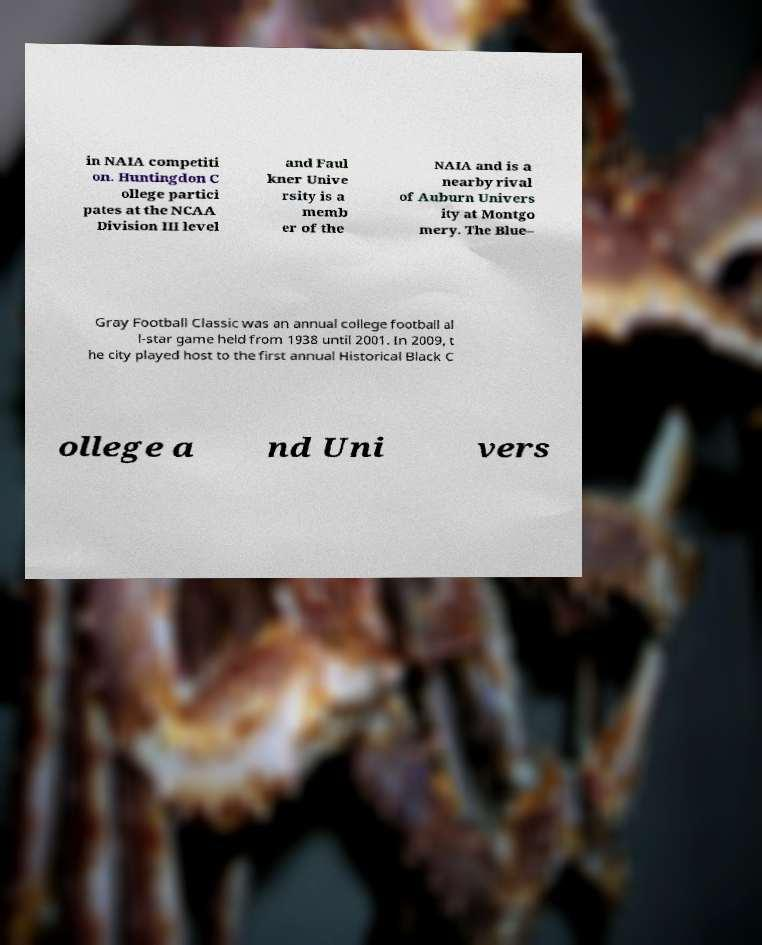What messages or text are displayed in this image? I need them in a readable, typed format. in NAIA competiti on. Huntingdon C ollege partici pates at the NCAA Division III level and Faul kner Unive rsity is a memb er of the NAIA and is a nearby rival of Auburn Univers ity at Montgo mery. The Blue– Gray Football Classic was an annual college football al l-star game held from 1938 until 2001. In 2009, t he city played host to the first annual Historical Black C ollege a nd Uni vers 